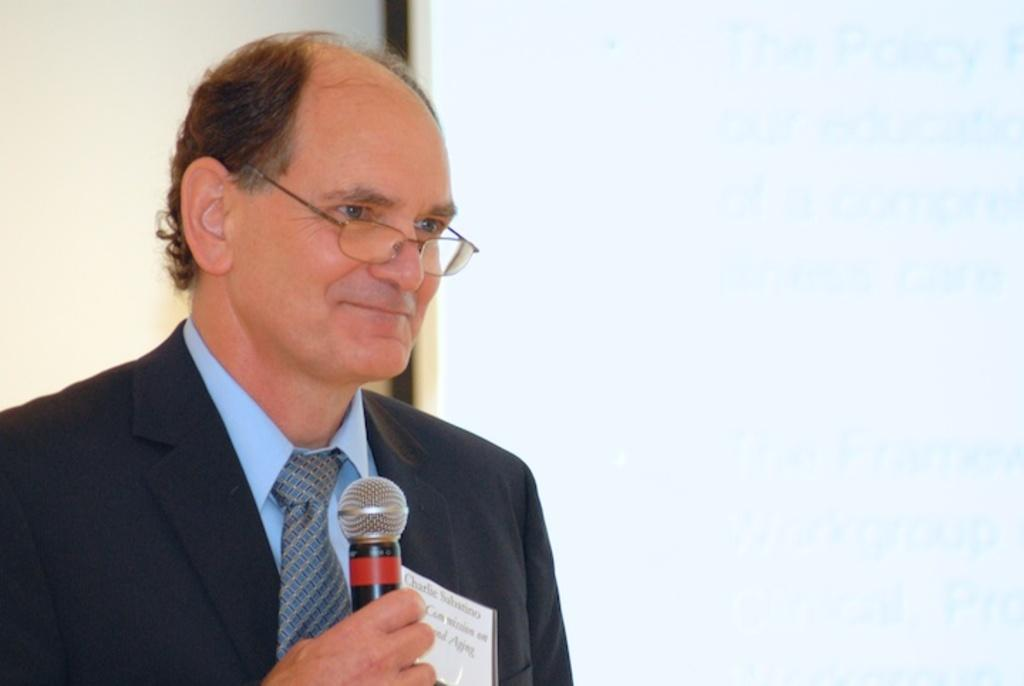What is the main subject of the image? There is a person in the image. What is the person holding in his hand? The person is holding a mic in his hand. What type of government is being discussed by the person holding the pencil in the image? There is no pencil present in the image, and the person is holding a mic, not discussing any type of government. 